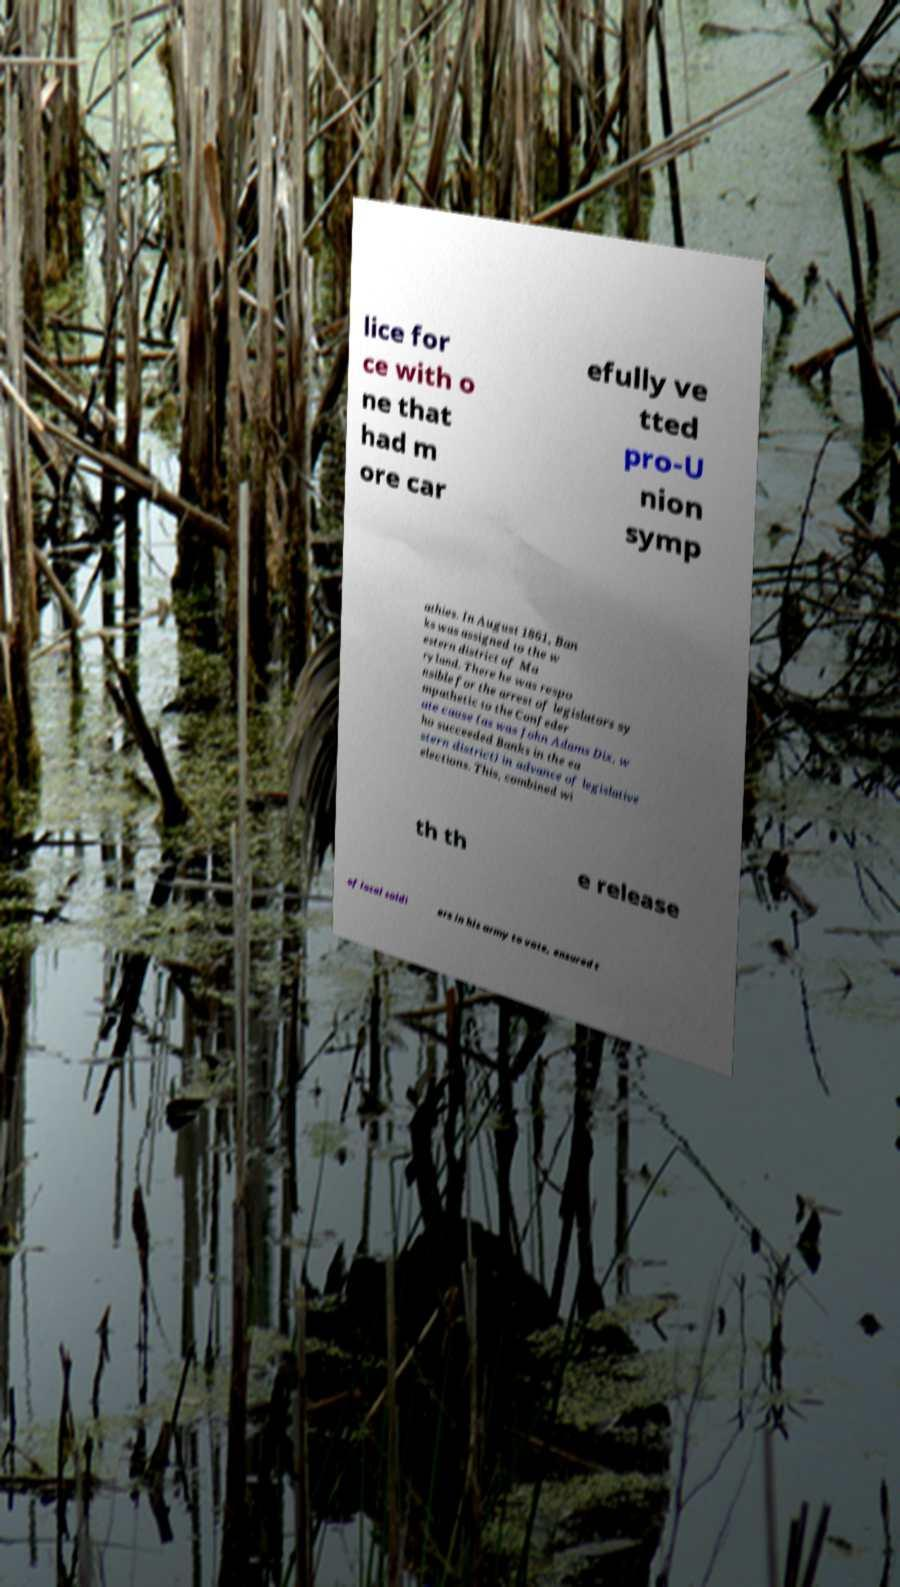Can you read and provide the text displayed in the image?This photo seems to have some interesting text. Can you extract and type it out for me? lice for ce with o ne that had m ore car efully ve tted pro-U nion symp athies. In August 1861, Ban ks was assigned to the w estern district of Ma ryland. There he was respo nsible for the arrest of legislators sy mpathetic to the Confeder ate cause (as was John Adams Dix, w ho succeeded Banks in the ea stern district) in advance of legislative elections. This, combined wi th th e release of local soldi ers in his army to vote, ensured t 